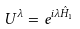<formula> <loc_0><loc_0><loc_500><loc_500>U ^ { \lambda } = e ^ { i \lambda \hat { H } _ { 1 } }</formula> 